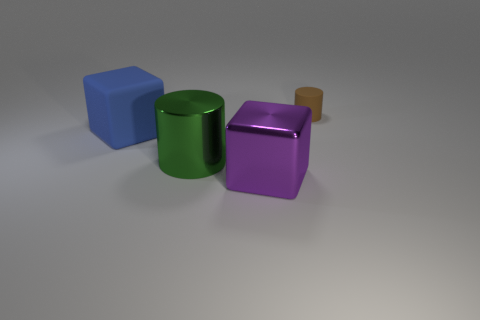How many other things are there of the same color as the large cylinder?
Ensure brevity in your answer.  0. Is the number of small yellow matte cubes less than the number of large blue things?
Provide a succinct answer. Yes. What color is the large object that is behind the metal block and in front of the big rubber block?
Ensure brevity in your answer.  Green. What material is the other object that is the same shape as the blue rubber object?
Offer a very short reply. Metal. Are there any other things that have the same size as the metallic cylinder?
Offer a very short reply. Yes. Is the number of metallic things greater than the number of brown rubber blocks?
Your answer should be compact. Yes. How big is the thing that is both to the right of the green cylinder and in front of the tiny brown thing?
Offer a terse response. Large. The large purple shiny thing has what shape?
Provide a succinct answer. Cube. How many rubber objects are the same shape as the green shiny object?
Your answer should be compact. 1. Are there fewer tiny brown matte cylinders on the left side of the large blue rubber object than brown rubber objects behind the brown matte object?
Provide a succinct answer. No. 